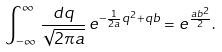Convert formula to latex. <formula><loc_0><loc_0><loc_500><loc_500>\int _ { - \infty } ^ { \infty } \, \frac { d q } { \sqrt { 2 \pi a } } \, e ^ { - \frac { 1 } { 2 a } q ^ { 2 } + q b } = e ^ { \frac { a b ^ { 2 } } { 2 } } .</formula> 